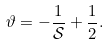<formula> <loc_0><loc_0><loc_500><loc_500>\vartheta = - \frac { 1 } { \mathcal { S } } + \frac { 1 } { 2 } .</formula> 